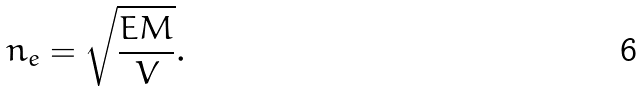Convert formula to latex. <formula><loc_0><loc_0><loc_500><loc_500>n _ { e } = \sqrt { \frac { E M } { V } } .</formula> 